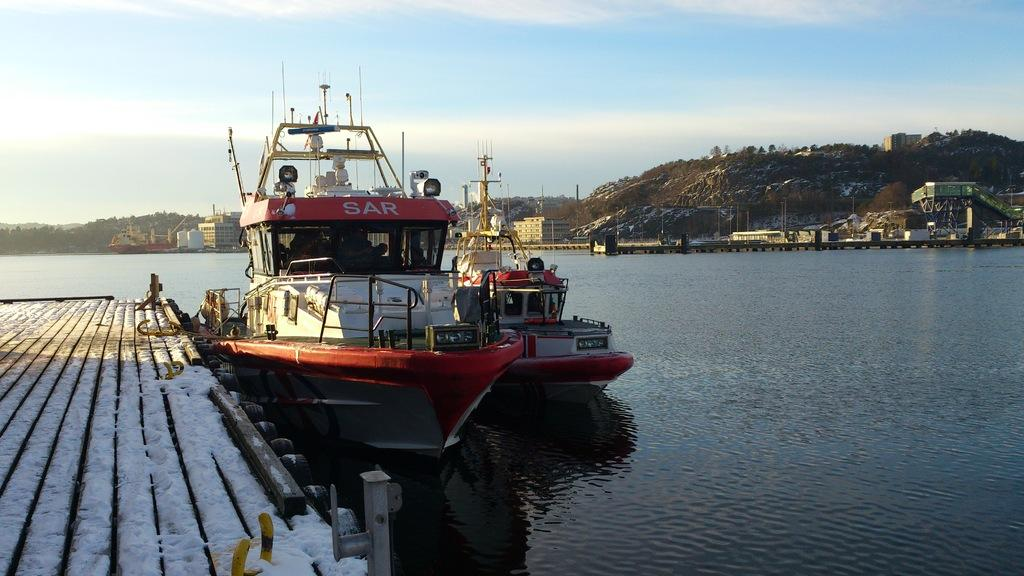<image>
Describe the image concisely. a boat named sar is sitting at the dockside 